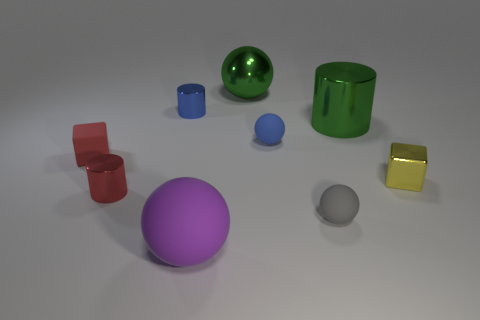What is the size of the cube on the left side of the large green shiny cylinder?
Offer a very short reply. Small. Is the rubber cube the same color as the big matte object?
Keep it short and to the point. No. What number of tiny objects are either brown rubber cylinders or green cylinders?
Ensure brevity in your answer.  0. Are there any other things of the same color as the metal block?
Your answer should be very brief. No. There is a red cylinder; are there any shiny cylinders right of it?
Keep it short and to the point. Yes. There is a cylinder that is in front of the cylinder that is right of the purple ball; how big is it?
Keep it short and to the point. Small. Are there the same number of red metallic cylinders that are on the right side of the yellow thing and blue cylinders left of the red metal thing?
Make the answer very short. Yes. There is a small ball that is in front of the tiny red matte block; are there any gray spheres that are left of it?
Provide a short and direct response. No. What number of gray spheres are right of the rubber ball on the right side of the tiny blue thing that is right of the blue cylinder?
Offer a terse response. 0. Is the number of blue things less than the number of small rubber cubes?
Provide a short and direct response. No. 